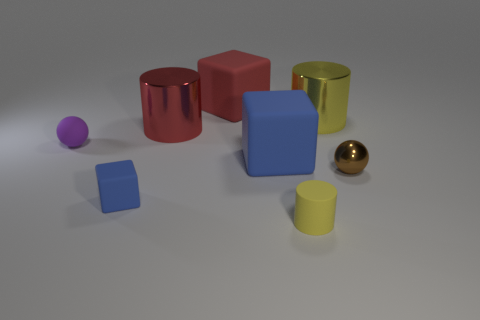The yellow matte thing has what size?
Your answer should be very brief. Small. There is a tiny brown metallic sphere; what number of red shiny objects are behind it?
Provide a succinct answer. 1. There is a yellow thing that is the same material as the tiny brown object; what is its shape?
Your answer should be compact. Cylinder. Is the number of purple objects behind the red metal object less than the number of metallic things to the left of the small brown sphere?
Offer a very short reply. Yes. Are there more big red blocks than metal cylinders?
Offer a terse response. No. What material is the small block?
Your response must be concise. Rubber. What color is the big rubber block behind the purple rubber sphere?
Make the answer very short. Red. Is the number of brown objects in front of the yellow shiny cylinder greater than the number of big blocks right of the yellow matte thing?
Ensure brevity in your answer.  Yes. How big is the sphere on the right side of the yellow cylinder that is in front of the brown sphere that is in front of the rubber ball?
Your answer should be compact. Small. Are there any objects of the same color as the small matte cylinder?
Make the answer very short. Yes. 